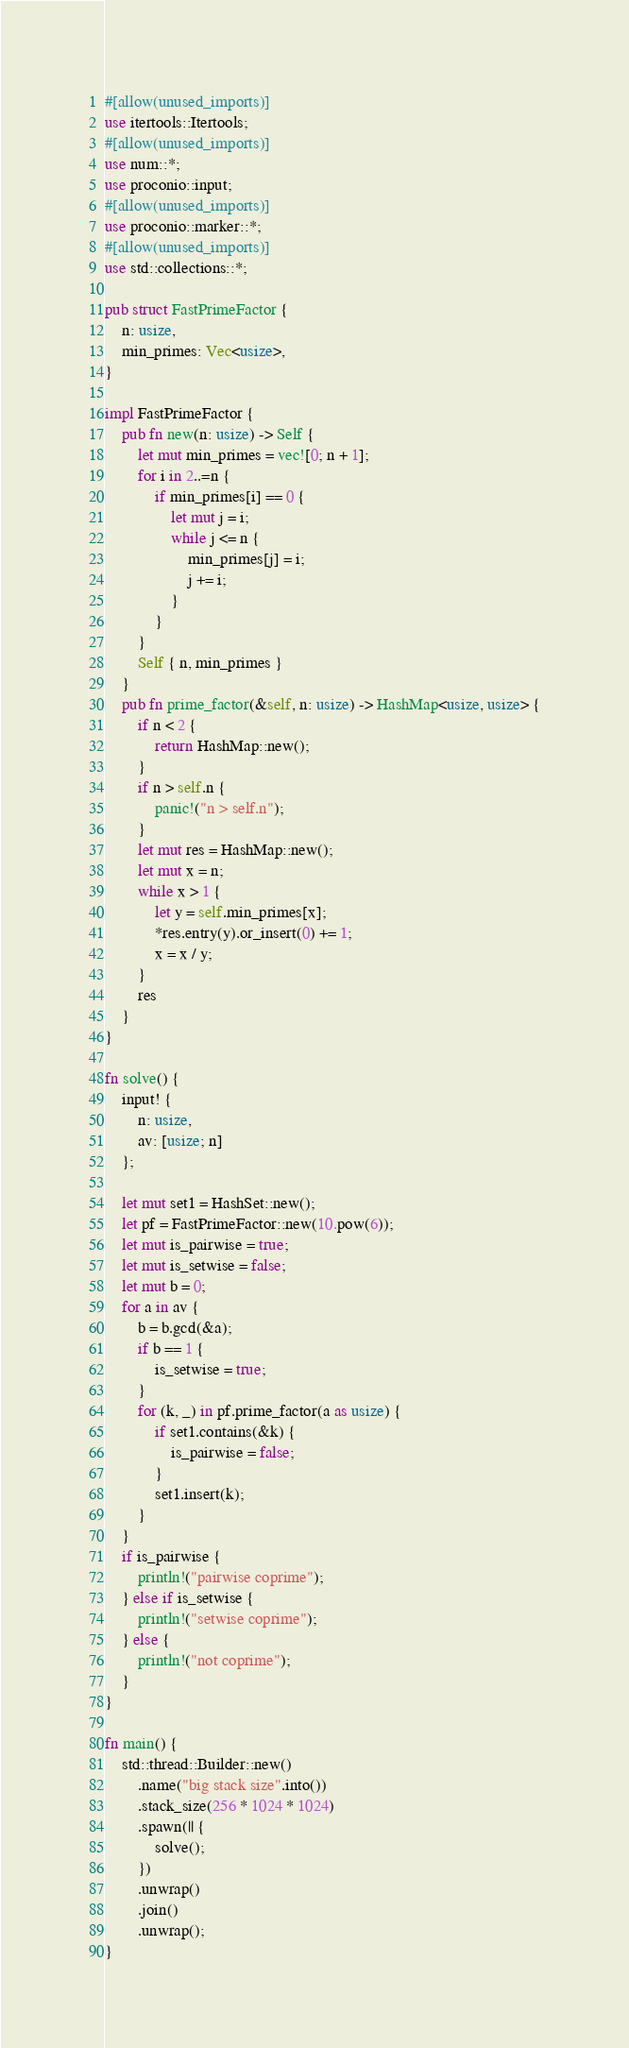<code> <loc_0><loc_0><loc_500><loc_500><_Rust_>#[allow(unused_imports)]
use itertools::Itertools;
#[allow(unused_imports)]
use num::*;
use proconio::input;
#[allow(unused_imports)]
use proconio::marker::*;
#[allow(unused_imports)]
use std::collections::*;

pub struct FastPrimeFactor {
    n: usize,
    min_primes: Vec<usize>,
}

impl FastPrimeFactor {
    pub fn new(n: usize) -> Self {
        let mut min_primes = vec![0; n + 1];
        for i in 2..=n {
            if min_primes[i] == 0 {
                let mut j = i;
                while j <= n {
                    min_primes[j] = i;
                    j += i;
                }
            }
        }
        Self { n, min_primes }
    }
    pub fn prime_factor(&self, n: usize) -> HashMap<usize, usize> {
        if n < 2 {
            return HashMap::new();
        }
        if n > self.n {
            panic!("n > self.n");
        }
        let mut res = HashMap::new();
        let mut x = n;
        while x > 1 {
            let y = self.min_primes[x];
            *res.entry(y).or_insert(0) += 1;
            x = x / y;
        }
        res
    }
}

fn solve() {
    input! {
        n: usize,
        av: [usize; n]
    };

    let mut set1 = HashSet::new();
    let pf = FastPrimeFactor::new(10.pow(6));
    let mut is_pairwise = true;
    let mut is_setwise = false;
    let mut b = 0;
    for a in av {
        b = b.gcd(&a);
        if b == 1 {
            is_setwise = true;
        }
        for (k, _) in pf.prime_factor(a as usize) {
            if set1.contains(&k) {
                is_pairwise = false;
            }
            set1.insert(k);
        }
    }
    if is_pairwise {
        println!("pairwise coprime");
    } else if is_setwise {
        println!("setwise coprime");
    } else {
        println!("not coprime");
    }
}

fn main() {
    std::thread::Builder::new()
        .name("big stack size".into())
        .stack_size(256 * 1024 * 1024)
        .spawn(|| {
            solve();
        })
        .unwrap()
        .join()
        .unwrap();
}
</code> 